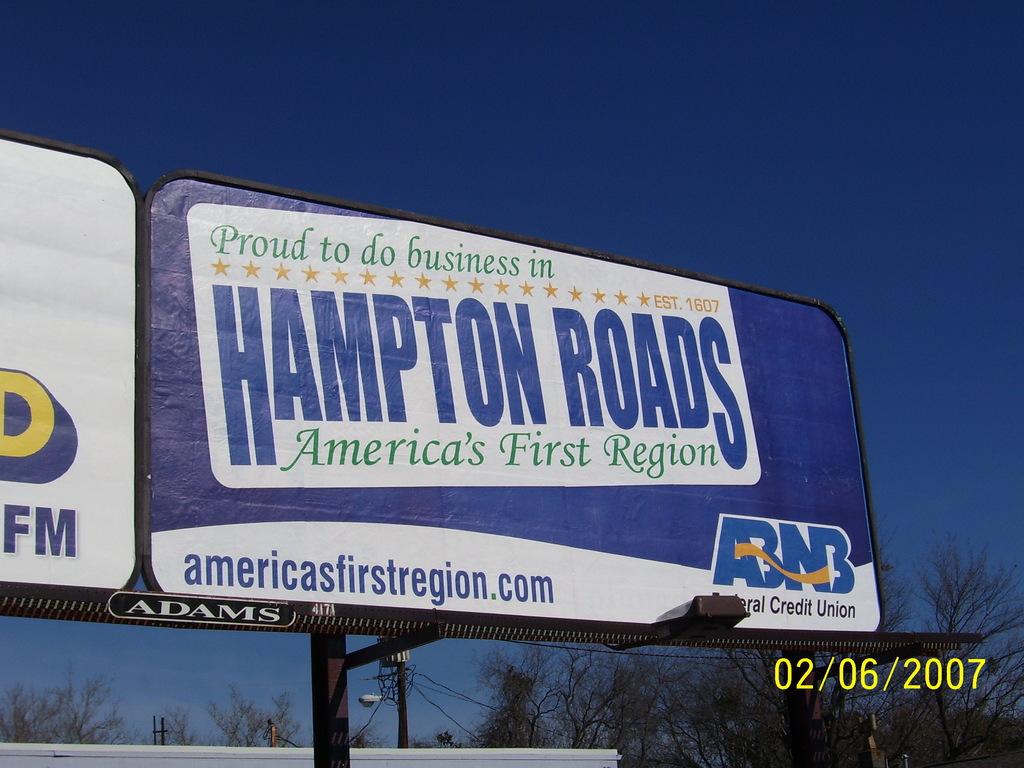What is the website listed on the sign?
Ensure brevity in your answer.  Americasfirstregion.com. What is the name of the credit union?
Provide a short and direct response. Abnb. 